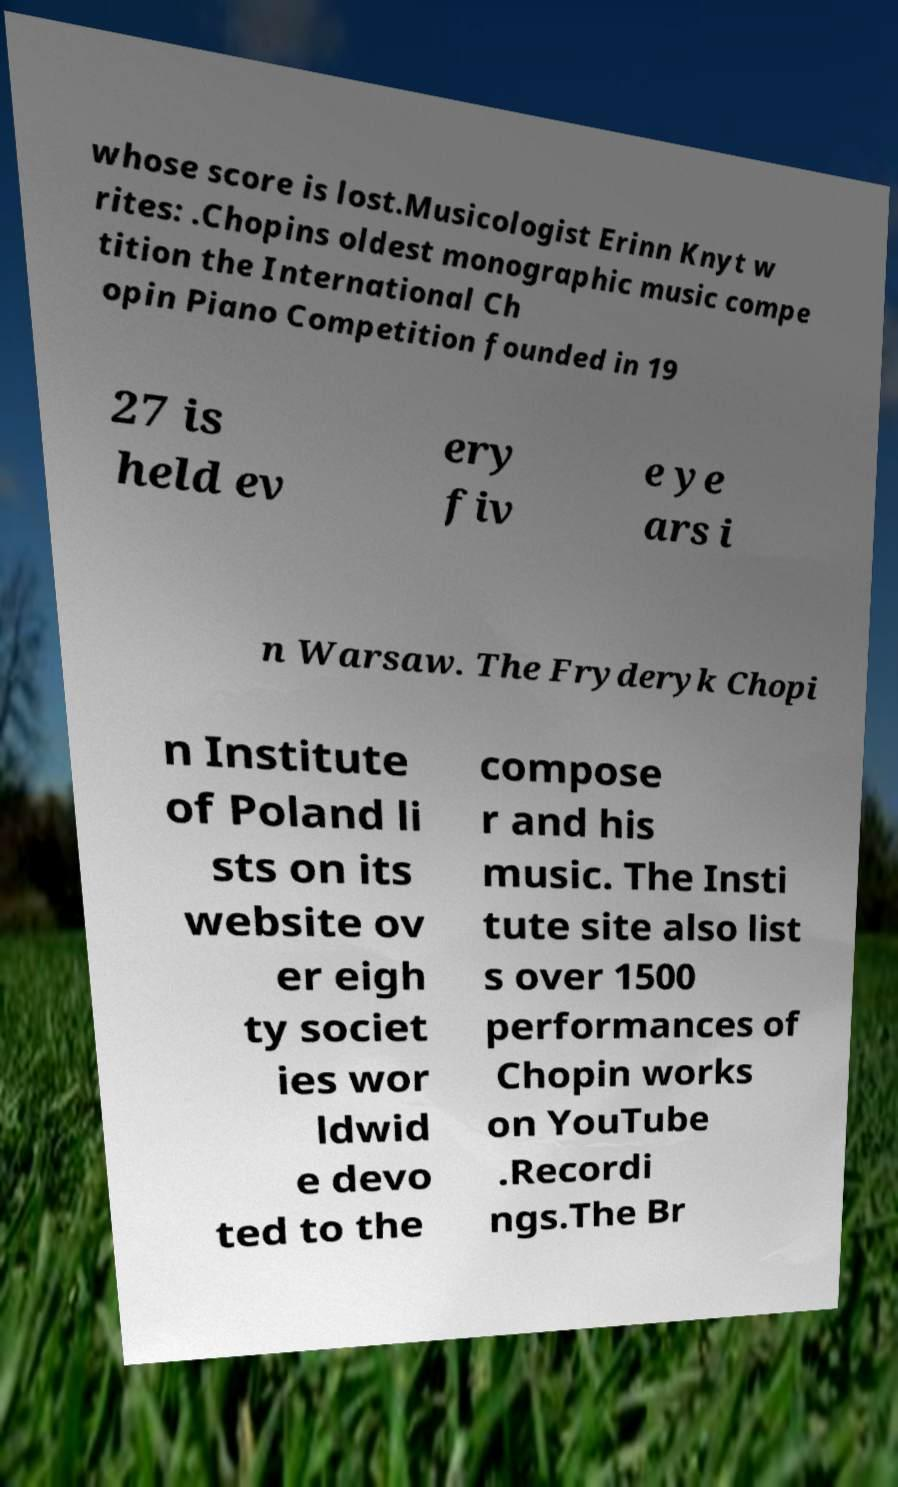There's text embedded in this image that I need extracted. Can you transcribe it verbatim? whose score is lost.Musicologist Erinn Knyt w rites: .Chopins oldest monographic music compe tition the International Ch opin Piano Competition founded in 19 27 is held ev ery fiv e ye ars i n Warsaw. The Fryderyk Chopi n Institute of Poland li sts on its website ov er eigh ty societ ies wor ldwid e devo ted to the compose r and his music. The Insti tute site also list s over 1500 performances of Chopin works on YouTube .Recordi ngs.The Br 